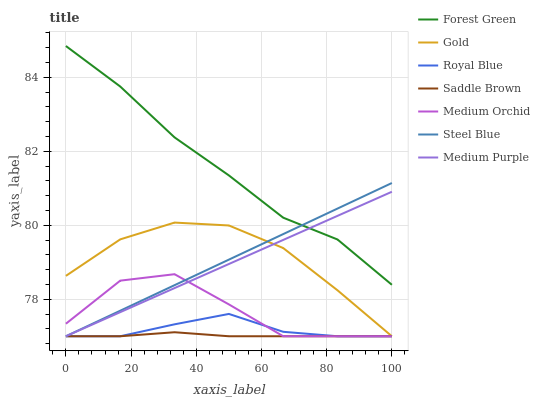Does Saddle Brown have the minimum area under the curve?
Answer yes or no. Yes. Does Forest Green have the maximum area under the curve?
Answer yes or no. Yes. Does Medium Orchid have the minimum area under the curve?
Answer yes or no. No. Does Medium Orchid have the maximum area under the curve?
Answer yes or no. No. Is Steel Blue the smoothest?
Answer yes or no. Yes. Is Medium Orchid the roughest?
Answer yes or no. Yes. Is Medium Orchid the smoothest?
Answer yes or no. No. Is Steel Blue the roughest?
Answer yes or no. No. Does Gold have the lowest value?
Answer yes or no. Yes. Does Forest Green have the lowest value?
Answer yes or no. No. Does Forest Green have the highest value?
Answer yes or no. Yes. Does Medium Orchid have the highest value?
Answer yes or no. No. Is Gold less than Forest Green?
Answer yes or no. Yes. Is Forest Green greater than Royal Blue?
Answer yes or no. Yes. Does Medium Orchid intersect Steel Blue?
Answer yes or no. Yes. Is Medium Orchid less than Steel Blue?
Answer yes or no. No. Is Medium Orchid greater than Steel Blue?
Answer yes or no. No. Does Gold intersect Forest Green?
Answer yes or no. No. 